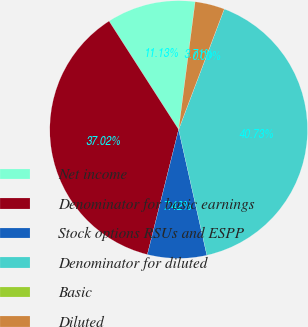<chart> <loc_0><loc_0><loc_500><loc_500><pie_chart><fcel>Net income<fcel>Denominator for basic earnings<fcel>Stock options RSUs and ESPP<fcel>Denominator for diluted<fcel>Basic<fcel>Diluted<nl><fcel>11.13%<fcel>37.02%<fcel>7.42%<fcel>40.73%<fcel>0.0%<fcel>3.71%<nl></chart> 